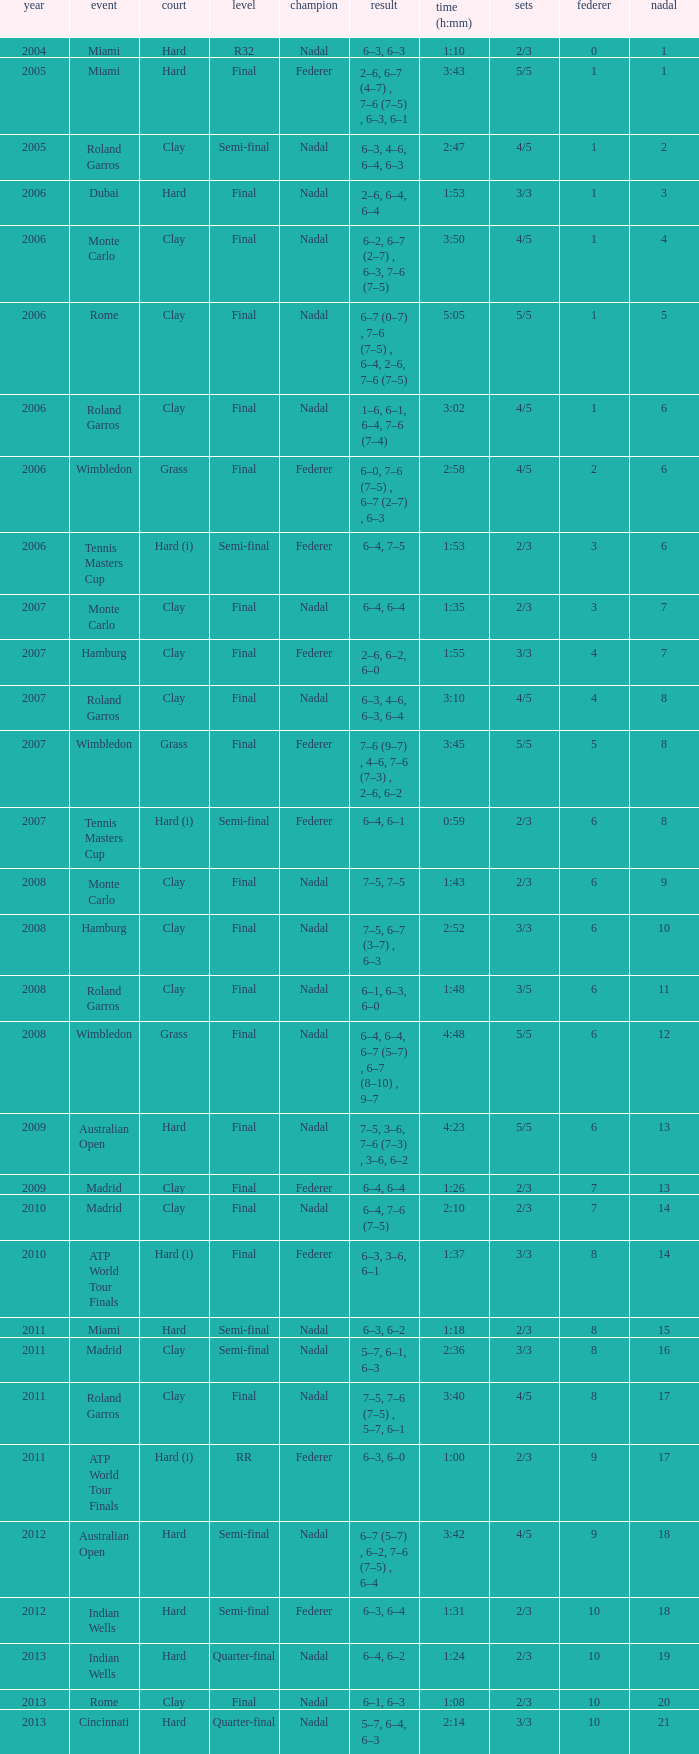What tournament did Nadal win and had a nadal of 16? Madrid. 